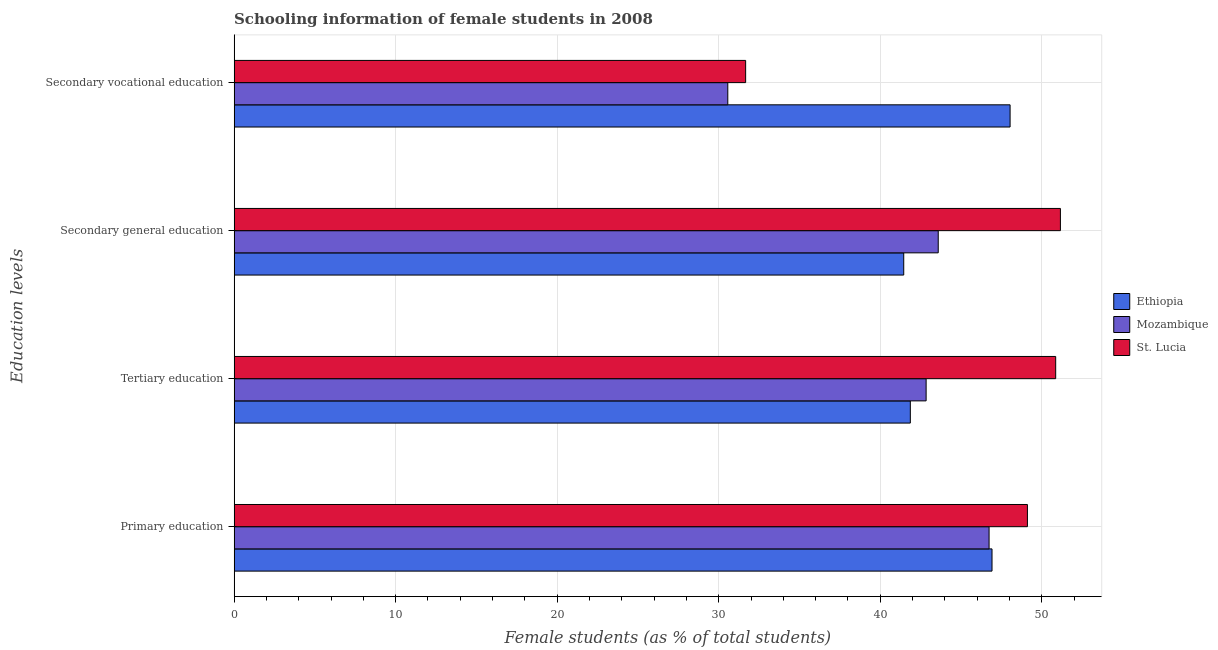How many different coloured bars are there?
Offer a very short reply. 3. How many groups of bars are there?
Keep it short and to the point. 4. What is the label of the 2nd group of bars from the top?
Your response must be concise. Secondary general education. What is the percentage of female students in secondary education in St. Lucia?
Provide a short and direct response. 51.15. Across all countries, what is the maximum percentage of female students in primary education?
Offer a very short reply. 49.11. Across all countries, what is the minimum percentage of female students in primary education?
Your response must be concise. 46.74. In which country was the percentage of female students in secondary education maximum?
Your answer should be very brief. St. Lucia. In which country was the percentage of female students in secondary education minimum?
Your response must be concise. Ethiopia. What is the total percentage of female students in secondary education in the graph?
Provide a succinct answer. 136.2. What is the difference between the percentage of female students in secondary vocational education in St. Lucia and that in Ethiopia?
Your answer should be very brief. -16.37. What is the difference between the percentage of female students in primary education in St. Lucia and the percentage of female students in secondary education in Ethiopia?
Give a very brief answer. 7.66. What is the average percentage of female students in primary education per country?
Offer a very short reply. 47.59. What is the difference between the percentage of female students in tertiary education and percentage of female students in secondary vocational education in Ethiopia?
Keep it short and to the point. -6.18. In how many countries, is the percentage of female students in primary education greater than 10 %?
Your answer should be very brief. 3. What is the ratio of the percentage of female students in primary education in St. Lucia to that in Mozambique?
Provide a succinct answer. 1.05. Is the percentage of female students in tertiary education in Mozambique less than that in St. Lucia?
Ensure brevity in your answer.  Yes. Is the difference between the percentage of female students in secondary vocational education in Mozambique and St. Lucia greater than the difference between the percentage of female students in tertiary education in Mozambique and St. Lucia?
Provide a succinct answer. Yes. What is the difference between the highest and the second highest percentage of female students in primary education?
Your response must be concise. 2.19. What is the difference between the highest and the lowest percentage of female students in tertiary education?
Give a very brief answer. 9. What does the 3rd bar from the top in Primary education represents?
Provide a succinct answer. Ethiopia. What does the 2nd bar from the bottom in Secondary general education represents?
Give a very brief answer. Mozambique. How many countries are there in the graph?
Offer a very short reply. 3. Does the graph contain grids?
Keep it short and to the point. Yes. Where does the legend appear in the graph?
Ensure brevity in your answer.  Center right. What is the title of the graph?
Offer a very short reply. Schooling information of female students in 2008. Does "Russian Federation" appear as one of the legend labels in the graph?
Provide a short and direct response. No. What is the label or title of the X-axis?
Make the answer very short. Female students (as % of total students). What is the label or title of the Y-axis?
Keep it short and to the point. Education levels. What is the Female students (as % of total students) in Ethiopia in Primary education?
Your answer should be compact. 46.92. What is the Female students (as % of total students) of Mozambique in Primary education?
Your answer should be very brief. 46.74. What is the Female students (as % of total students) of St. Lucia in Primary education?
Offer a terse response. 49.11. What is the Female students (as % of total students) in Ethiopia in Tertiary education?
Ensure brevity in your answer.  41.86. What is the Female students (as % of total students) in Mozambique in Tertiary education?
Ensure brevity in your answer.  42.84. What is the Female students (as % of total students) of St. Lucia in Tertiary education?
Provide a succinct answer. 50.86. What is the Female students (as % of total students) of Ethiopia in Secondary general education?
Provide a short and direct response. 41.45. What is the Female students (as % of total students) in Mozambique in Secondary general education?
Keep it short and to the point. 43.59. What is the Female students (as % of total students) of St. Lucia in Secondary general education?
Ensure brevity in your answer.  51.15. What is the Female students (as % of total students) in Ethiopia in Secondary vocational education?
Offer a very short reply. 48.04. What is the Female students (as % of total students) of Mozambique in Secondary vocational education?
Provide a succinct answer. 30.56. What is the Female students (as % of total students) of St. Lucia in Secondary vocational education?
Provide a succinct answer. 31.67. Across all Education levels, what is the maximum Female students (as % of total students) in Ethiopia?
Your answer should be compact. 48.04. Across all Education levels, what is the maximum Female students (as % of total students) in Mozambique?
Your response must be concise. 46.74. Across all Education levels, what is the maximum Female students (as % of total students) of St. Lucia?
Your answer should be very brief. 51.15. Across all Education levels, what is the minimum Female students (as % of total students) of Ethiopia?
Give a very brief answer. 41.45. Across all Education levels, what is the minimum Female students (as % of total students) of Mozambique?
Offer a very short reply. 30.56. Across all Education levels, what is the minimum Female students (as % of total students) in St. Lucia?
Provide a short and direct response. 31.67. What is the total Female students (as % of total students) in Ethiopia in the graph?
Your answer should be compact. 178.27. What is the total Female students (as % of total students) in Mozambique in the graph?
Offer a very short reply. 163.73. What is the total Female students (as % of total students) of St. Lucia in the graph?
Make the answer very short. 182.79. What is the difference between the Female students (as % of total students) in Ethiopia in Primary education and that in Tertiary education?
Offer a terse response. 5.06. What is the difference between the Female students (as % of total students) in Mozambique in Primary education and that in Tertiary education?
Keep it short and to the point. 3.9. What is the difference between the Female students (as % of total students) of St. Lucia in Primary education and that in Tertiary education?
Ensure brevity in your answer.  -1.75. What is the difference between the Female students (as % of total students) of Ethiopia in Primary education and that in Secondary general education?
Your answer should be very brief. 5.46. What is the difference between the Female students (as % of total students) of Mozambique in Primary education and that in Secondary general education?
Ensure brevity in your answer.  3.15. What is the difference between the Female students (as % of total students) in St. Lucia in Primary education and that in Secondary general education?
Keep it short and to the point. -2.04. What is the difference between the Female students (as % of total students) of Ethiopia in Primary education and that in Secondary vocational education?
Keep it short and to the point. -1.12. What is the difference between the Female students (as % of total students) in Mozambique in Primary education and that in Secondary vocational education?
Make the answer very short. 16.17. What is the difference between the Female students (as % of total students) in St. Lucia in Primary education and that in Secondary vocational education?
Give a very brief answer. 17.45. What is the difference between the Female students (as % of total students) of Ethiopia in Tertiary education and that in Secondary general education?
Offer a terse response. 0.41. What is the difference between the Female students (as % of total students) of Mozambique in Tertiary education and that in Secondary general education?
Your response must be concise. -0.75. What is the difference between the Female students (as % of total students) of St. Lucia in Tertiary education and that in Secondary general education?
Offer a very short reply. -0.29. What is the difference between the Female students (as % of total students) of Ethiopia in Tertiary education and that in Secondary vocational education?
Your response must be concise. -6.18. What is the difference between the Female students (as % of total students) in Mozambique in Tertiary education and that in Secondary vocational education?
Keep it short and to the point. 12.28. What is the difference between the Female students (as % of total students) in St. Lucia in Tertiary education and that in Secondary vocational education?
Offer a very short reply. 19.2. What is the difference between the Female students (as % of total students) in Ethiopia in Secondary general education and that in Secondary vocational education?
Ensure brevity in your answer.  -6.58. What is the difference between the Female students (as % of total students) in Mozambique in Secondary general education and that in Secondary vocational education?
Provide a succinct answer. 13.03. What is the difference between the Female students (as % of total students) of St. Lucia in Secondary general education and that in Secondary vocational education?
Your response must be concise. 19.49. What is the difference between the Female students (as % of total students) in Ethiopia in Primary education and the Female students (as % of total students) in Mozambique in Tertiary education?
Your answer should be very brief. 4.08. What is the difference between the Female students (as % of total students) of Ethiopia in Primary education and the Female students (as % of total students) of St. Lucia in Tertiary education?
Offer a very short reply. -3.94. What is the difference between the Female students (as % of total students) in Mozambique in Primary education and the Female students (as % of total students) in St. Lucia in Tertiary education?
Ensure brevity in your answer.  -4.12. What is the difference between the Female students (as % of total students) in Ethiopia in Primary education and the Female students (as % of total students) in Mozambique in Secondary general education?
Give a very brief answer. 3.33. What is the difference between the Female students (as % of total students) of Ethiopia in Primary education and the Female students (as % of total students) of St. Lucia in Secondary general education?
Your answer should be compact. -4.23. What is the difference between the Female students (as % of total students) in Mozambique in Primary education and the Female students (as % of total students) in St. Lucia in Secondary general education?
Give a very brief answer. -4.42. What is the difference between the Female students (as % of total students) in Ethiopia in Primary education and the Female students (as % of total students) in Mozambique in Secondary vocational education?
Make the answer very short. 16.36. What is the difference between the Female students (as % of total students) in Ethiopia in Primary education and the Female students (as % of total students) in St. Lucia in Secondary vocational education?
Your answer should be very brief. 15.25. What is the difference between the Female students (as % of total students) of Mozambique in Primary education and the Female students (as % of total students) of St. Lucia in Secondary vocational education?
Ensure brevity in your answer.  15.07. What is the difference between the Female students (as % of total students) in Ethiopia in Tertiary education and the Female students (as % of total students) in Mozambique in Secondary general education?
Your answer should be very brief. -1.73. What is the difference between the Female students (as % of total students) of Ethiopia in Tertiary education and the Female students (as % of total students) of St. Lucia in Secondary general education?
Your response must be concise. -9.29. What is the difference between the Female students (as % of total students) of Mozambique in Tertiary education and the Female students (as % of total students) of St. Lucia in Secondary general education?
Your answer should be very brief. -8.31. What is the difference between the Female students (as % of total students) in Ethiopia in Tertiary education and the Female students (as % of total students) in Mozambique in Secondary vocational education?
Provide a succinct answer. 11.3. What is the difference between the Female students (as % of total students) of Ethiopia in Tertiary education and the Female students (as % of total students) of St. Lucia in Secondary vocational education?
Provide a short and direct response. 10.2. What is the difference between the Female students (as % of total students) of Mozambique in Tertiary education and the Female students (as % of total students) of St. Lucia in Secondary vocational education?
Make the answer very short. 11.17. What is the difference between the Female students (as % of total students) of Ethiopia in Secondary general education and the Female students (as % of total students) of Mozambique in Secondary vocational education?
Your answer should be compact. 10.89. What is the difference between the Female students (as % of total students) of Ethiopia in Secondary general education and the Female students (as % of total students) of St. Lucia in Secondary vocational education?
Your response must be concise. 9.79. What is the difference between the Female students (as % of total students) of Mozambique in Secondary general education and the Female students (as % of total students) of St. Lucia in Secondary vocational education?
Your answer should be very brief. 11.92. What is the average Female students (as % of total students) in Ethiopia per Education levels?
Give a very brief answer. 44.57. What is the average Female students (as % of total students) in Mozambique per Education levels?
Keep it short and to the point. 40.93. What is the average Female students (as % of total students) of St. Lucia per Education levels?
Your answer should be very brief. 45.7. What is the difference between the Female students (as % of total students) of Ethiopia and Female students (as % of total students) of Mozambique in Primary education?
Give a very brief answer. 0.18. What is the difference between the Female students (as % of total students) in Ethiopia and Female students (as % of total students) in St. Lucia in Primary education?
Your response must be concise. -2.19. What is the difference between the Female students (as % of total students) of Mozambique and Female students (as % of total students) of St. Lucia in Primary education?
Offer a terse response. -2.37. What is the difference between the Female students (as % of total students) of Ethiopia and Female students (as % of total students) of Mozambique in Tertiary education?
Offer a terse response. -0.98. What is the difference between the Female students (as % of total students) of Ethiopia and Female students (as % of total students) of St. Lucia in Tertiary education?
Provide a succinct answer. -9. What is the difference between the Female students (as % of total students) in Mozambique and Female students (as % of total students) in St. Lucia in Tertiary education?
Ensure brevity in your answer.  -8.02. What is the difference between the Female students (as % of total students) in Ethiopia and Female students (as % of total students) in Mozambique in Secondary general education?
Your response must be concise. -2.14. What is the difference between the Female students (as % of total students) of Ethiopia and Female students (as % of total students) of St. Lucia in Secondary general education?
Your answer should be very brief. -9.7. What is the difference between the Female students (as % of total students) in Mozambique and Female students (as % of total students) in St. Lucia in Secondary general education?
Your answer should be very brief. -7.56. What is the difference between the Female students (as % of total students) in Ethiopia and Female students (as % of total students) in Mozambique in Secondary vocational education?
Offer a terse response. 17.48. What is the difference between the Female students (as % of total students) of Ethiopia and Female students (as % of total students) of St. Lucia in Secondary vocational education?
Offer a very short reply. 16.37. What is the difference between the Female students (as % of total students) of Mozambique and Female students (as % of total students) of St. Lucia in Secondary vocational education?
Ensure brevity in your answer.  -1.1. What is the ratio of the Female students (as % of total students) in Ethiopia in Primary education to that in Tertiary education?
Keep it short and to the point. 1.12. What is the ratio of the Female students (as % of total students) in Mozambique in Primary education to that in Tertiary education?
Make the answer very short. 1.09. What is the ratio of the Female students (as % of total students) in St. Lucia in Primary education to that in Tertiary education?
Keep it short and to the point. 0.97. What is the ratio of the Female students (as % of total students) in Ethiopia in Primary education to that in Secondary general education?
Give a very brief answer. 1.13. What is the ratio of the Female students (as % of total students) of Mozambique in Primary education to that in Secondary general education?
Your answer should be compact. 1.07. What is the ratio of the Female students (as % of total students) of St. Lucia in Primary education to that in Secondary general education?
Keep it short and to the point. 0.96. What is the ratio of the Female students (as % of total students) of Ethiopia in Primary education to that in Secondary vocational education?
Provide a short and direct response. 0.98. What is the ratio of the Female students (as % of total students) of Mozambique in Primary education to that in Secondary vocational education?
Keep it short and to the point. 1.53. What is the ratio of the Female students (as % of total students) in St. Lucia in Primary education to that in Secondary vocational education?
Offer a very short reply. 1.55. What is the ratio of the Female students (as % of total students) of Ethiopia in Tertiary education to that in Secondary general education?
Offer a terse response. 1.01. What is the ratio of the Female students (as % of total students) of Mozambique in Tertiary education to that in Secondary general education?
Offer a terse response. 0.98. What is the ratio of the Female students (as % of total students) of St. Lucia in Tertiary education to that in Secondary general education?
Provide a succinct answer. 0.99. What is the ratio of the Female students (as % of total students) in Ethiopia in Tertiary education to that in Secondary vocational education?
Provide a succinct answer. 0.87. What is the ratio of the Female students (as % of total students) of Mozambique in Tertiary education to that in Secondary vocational education?
Your answer should be compact. 1.4. What is the ratio of the Female students (as % of total students) of St. Lucia in Tertiary education to that in Secondary vocational education?
Ensure brevity in your answer.  1.61. What is the ratio of the Female students (as % of total students) in Ethiopia in Secondary general education to that in Secondary vocational education?
Ensure brevity in your answer.  0.86. What is the ratio of the Female students (as % of total students) of Mozambique in Secondary general education to that in Secondary vocational education?
Your response must be concise. 1.43. What is the ratio of the Female students (as % of total students) of St. Lucia in Secondary general education to that in Secondary vocational education?
Make the answer very short. 1.62. What is the difference between the highest and the second highest Female students (as % of total students) of Ethiopia?
Give a very brief answer. 1.12. What is the difference between the highest and the second highest Female students (as % of total students) of Mozambique?
Give a very brief answer. 3.15. What is the difference between the highest and the second highest Female students (as % of total students) in St. Lucia?
Your response must be concise. 0.29. What is the difference between the highest and the lowest Female students (as % of total students) of Ethiopia?
Make the answer very short. 6.58. What is the difference between the highest and the lowest Female students (as % of total students) of Mozambique?
Your answer should be compact. 16.17. What is the difference between the highest and the lowest Female students (as % of total students) of St. Lucia?
Give a very brief answer. 19.49. 